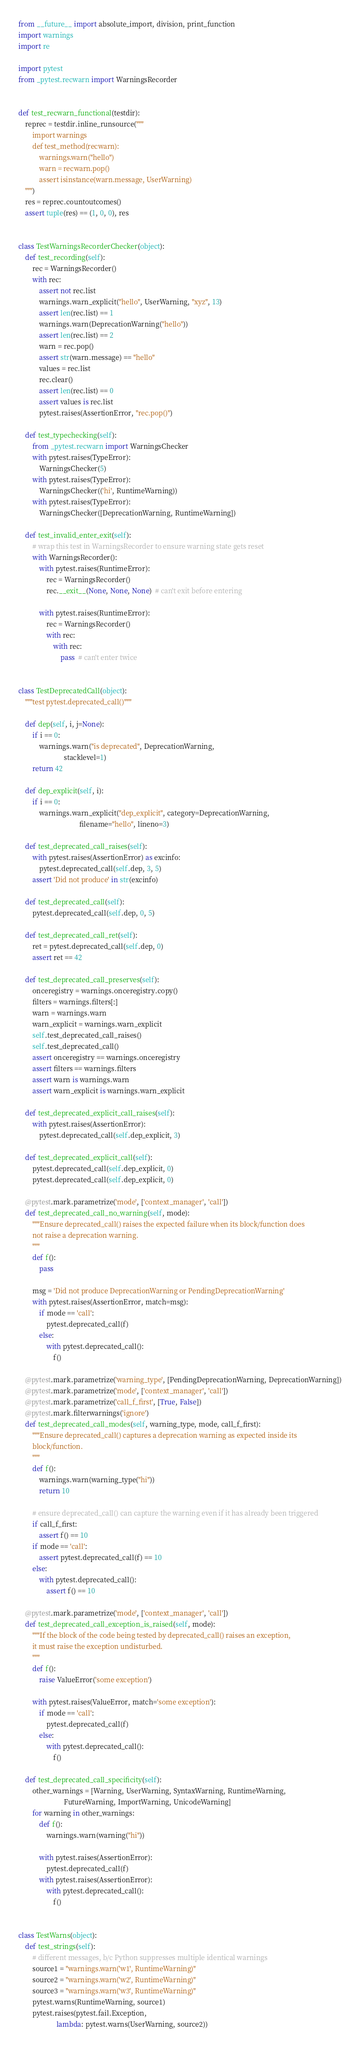Convert code to text. <code><loc_0><loc_0><loc_500><loc_500><_Python_>from __future__ import absolute_import, division, print_function
import warnings
import re

import pytest
from _pytest.recwarn import WarningsRecorder


def test_recwarn_functional(testdir):
    reprec = testdir.inline_runsource("""
        import warnings
        def test_method(recwarn):
            warnings.warn("hello")
            warn = recwarn.pop()
            assert isinstance(warn.message, UserWarning)
    """)
    res = reprec.countoutcomes()
    assert tuple(res) == (1, 0, 0), res


class TestWarningsRecorderChecker(object):
    def test_recording(self):
        rec = WarningsRecorder()
        with rec:
            assert not rec.list
            warnings.warn_explicit("hello", UserWarning, "xyz", 13)
            assert len(rec.list) == 1
            warnings.warn(DeprecationWarning("hello"))
            assert len(rec.list) == 2
            warn = rec.pop()
            assert str(warn.message) == "hello"
            values = rec.list
            rec.clear()
            assert len(rec.list) == 0
            assert values is rec.list
            pytest.raises(AssertionError, "rec.pop()")

    def test_typechecking(self):
        from _pytest.recwarn import WarningsChecker
        with pytest.raises(TypeError):
            WarningsChecker(5)
        with pytest.raises(TypeError):
            WarningsChecker(('hi', RuntimeWarning))
        with pytest.raises(TypeError):
            WarningsChecker([DeprecationWarning, RuntimeWarning])

    def test_invalid_enter_exit(self):
        # wrap this test in WarningsRecorder to ensure warning state gets reset
        with WarningsRecorder():
            with pytest.raises(RuntimeError):
                rec = WarningsRecorder()
                rec.__exit__(None, None, None)  # can't exit before entering

            with pytest.raises(RuntimeError):
                rec = WarningsRecorder()
                with rec:
                    with rec:
                        pass  # can't enter twice


class TestDeprecatedCall(object):
    """test pytest.deprecated_call()"""

    def dep(self, i, j=None):
        if i == 0:
            warnings.warn("is deprecated", DeprecationWarning,
                          stacklevel=1)
        return 42

    def dep_explicit(self, i):
        if i == 0:
            warnings.warn_explicit("dep_explicit", category=DeprecationWarning,
                                   filename="hello", lineno=3)

    def test_deprecated_call_raises(self):
        with pytest.raises(AssertionError) as excinfo:
            pytest.deprecated_call(self.dep, 3, 5)
        assert 'Did not produce' in str(excinfo)

    def test_deprecated_call(self):
        pytest.deprecated_call(self.dep, 0, 5)

    def test_deprecated_call_ret(self):
        ret = pytest.deprecated_call(self.dep, 0)
        assert ret == 42

    def test_deprecated_call_preserves(self):
        onceregistry = warnings.onceregistry.copy()
        filters = warnings.filters[:]
        warn = warnings.warn
        warn_explicit = warnings.warn_explicit
        self.test_deprecated_call_raises()
        self.test_deprecated_call()
        assert onceregistry == warnings.onceregistry
        assert filters == warnings.filters
        assert warn is warnings.warn
        assert warn_explicit is warnings.warn_explicit

    def test_deprecated_explicit_call_raises(self):
        with pytest.raises(AssertionError):
            pytest.deprecated_call(self.dep_explicit, 3)

    def test_deprecated_explicit_call(self):
        pytest.deprecated_call(self.dep_explicit, 0)
        pytest.deprecated_call(self.dep_explicit, 0)

    @pytest.mark.parametrize('mode', ['context_manager', 'call'])
    def test_deprecated_call_no_warning(self, mode):
        """Ensure deprecated_call() raises the expected failure when its block/function does
        not raise a deprecation warning.
        """
        def f():
            pass

        msg = 'Did not produce DeprecationWarning or PendingDeprecationWarning'
        with pytest.raises(AssertionError, match=msg):
            if mode == 'call':
                pytest.deprecated_call(f)
            else:
                with pytest.deprecated_call():
                    f()

    @pytest.mark.parametrize('warning_type', [PendingDeprecationWarning, DeprecationWarning])
    @pytest.mark.parametrize('mode', ['context_manager', 'call'])
    @pytest.mark.parametrize('call_f_first', [True, False])
    @pytest.mark.filterwarnings('ignore')
    def test_deprecated_call_modes(self, warning_type, mode, call_f_first):
        """Ensure deprecated_call() captures a deprecation warning as expected inside its
        block/function.
        """
        def f():
            warnings.warn(warning_type("hi"))
            return 10

        # ensure deprecated_call() can capture the warning even if it has already been triggered
        if call_f_first:
            assert f() == 10
        if mode == 'call':
            assert pytest.deprecated_call(f) == 10
        else:
            with pytest.deprecated_call():
                assert f() == 10

    @pytest.mark.parametrize('mode', ['context_manager', 'call'])
    def test_deprecated_call_exception_is_raised(self, mode):
        """If the block of the code being tested by deprecated_call() raises an exception,
        it must raise the exception undisturbed.
        """
        def f():
            raise ValueError('some exception')

        with pytest.raises(ValueError, match='some exception'):
            if mode == 'call':
                pytest.deprecated_call(f)
            else:
                with pytest.deprecated_call():
                    f()

    def test_deprecated_call_specificity(self):
        other_warnings = [Warning, UserWarning, SyntaxWarning, RuntimeWarning,
                          FutureWarning, ImportWarning, UnicodeWarning]
        for warning in other_warnings:
            def f():
                warnings.warn(warning("hi"))

            with pytest.raises(AssertionError):
                pytest.deprecated_call(f)
            with pytest.raises(AssertionError):
                with pytest.deprecated_call():
                    f()


class TestWarns(object):
    def test_strings(self):
        # different messages, b/c Python suppresses multiple identical warnings
        source1 = "warnings.warn('w1', RuntimeWarning)"
        source2 = "warnings.warn('w2', RuntimeWarning)"
        source3 = "warnings.warn('w3', RuntimeWarning)"
        pytest.warns(RuntimeWarning, source1)
        pytest.raises(pytest.fail.Exception,
                      lambda: pytest.warns(UserWarning, source2))</code> 